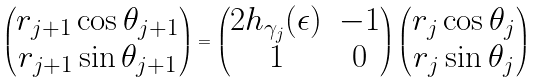Convert formula to latex. <formula><loc_0><loc_0><loc_500><loc_500>\begin{pmatrix} r _ { j + 1 } \cos \theta _ { j + 1 } \\ r _ { j + 1 } \sin \theta _ { j + 1 } \end{pmatrix} = \begin{pmatrix} 2 h _ { \gamma _ { j } } ( \epsilon ) & - 1 \\ 1 & 0 \end{pmatrix} \begin{pmatrix} r _ { j } \cos \theta _ { j } \\ r _ { j } \sin \theta _ { j } \end{pmatrix}</formula> 